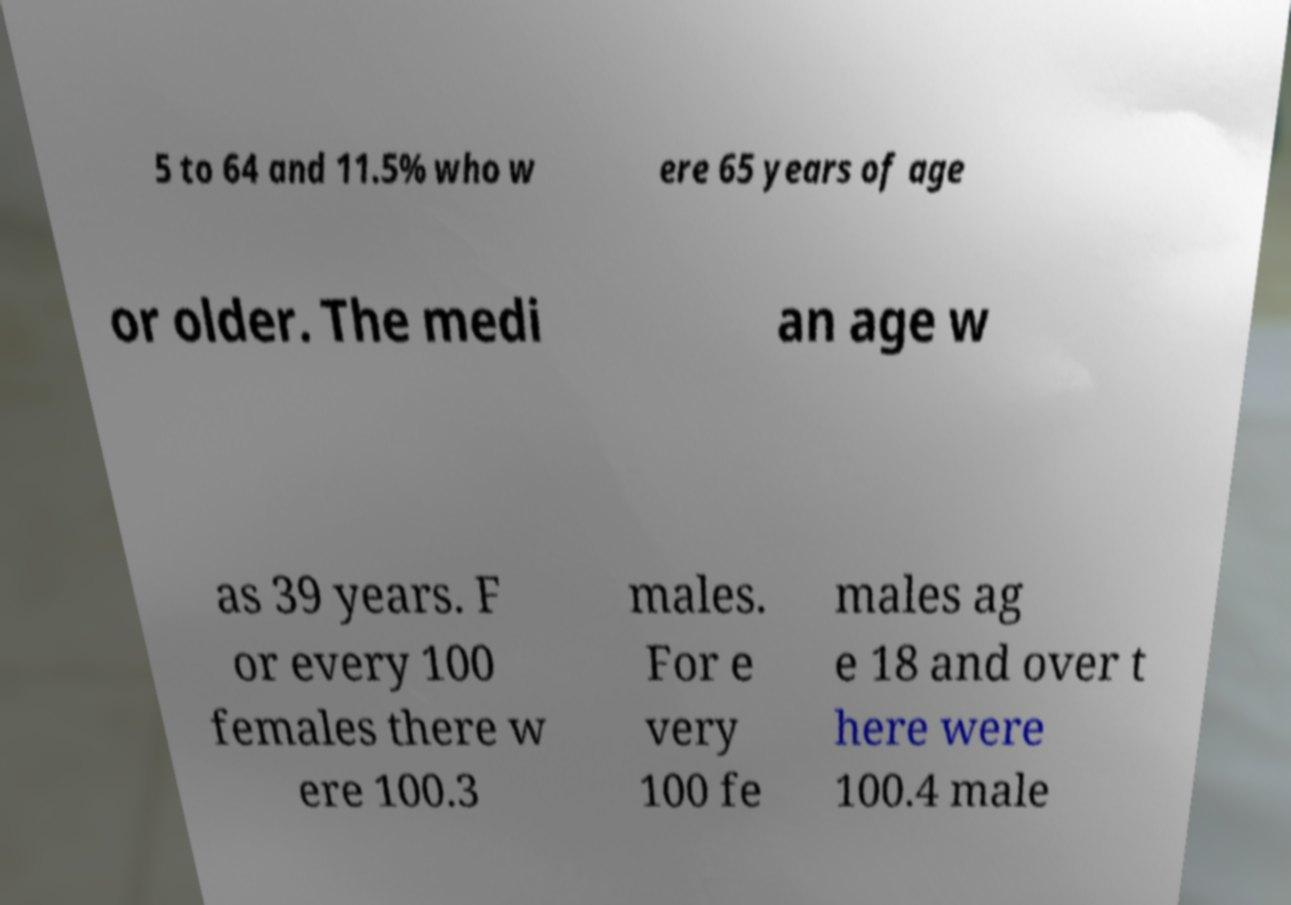Please read and relay the text visible in this image. What does it say? 5 to 64 and 11.5% who w ere 65 years of age or older. The medi an age w as 39 years. F or every 100 females there w ere 100.3 males. For e very 100 fe males ag e 18 and over t here were 100.4 male 